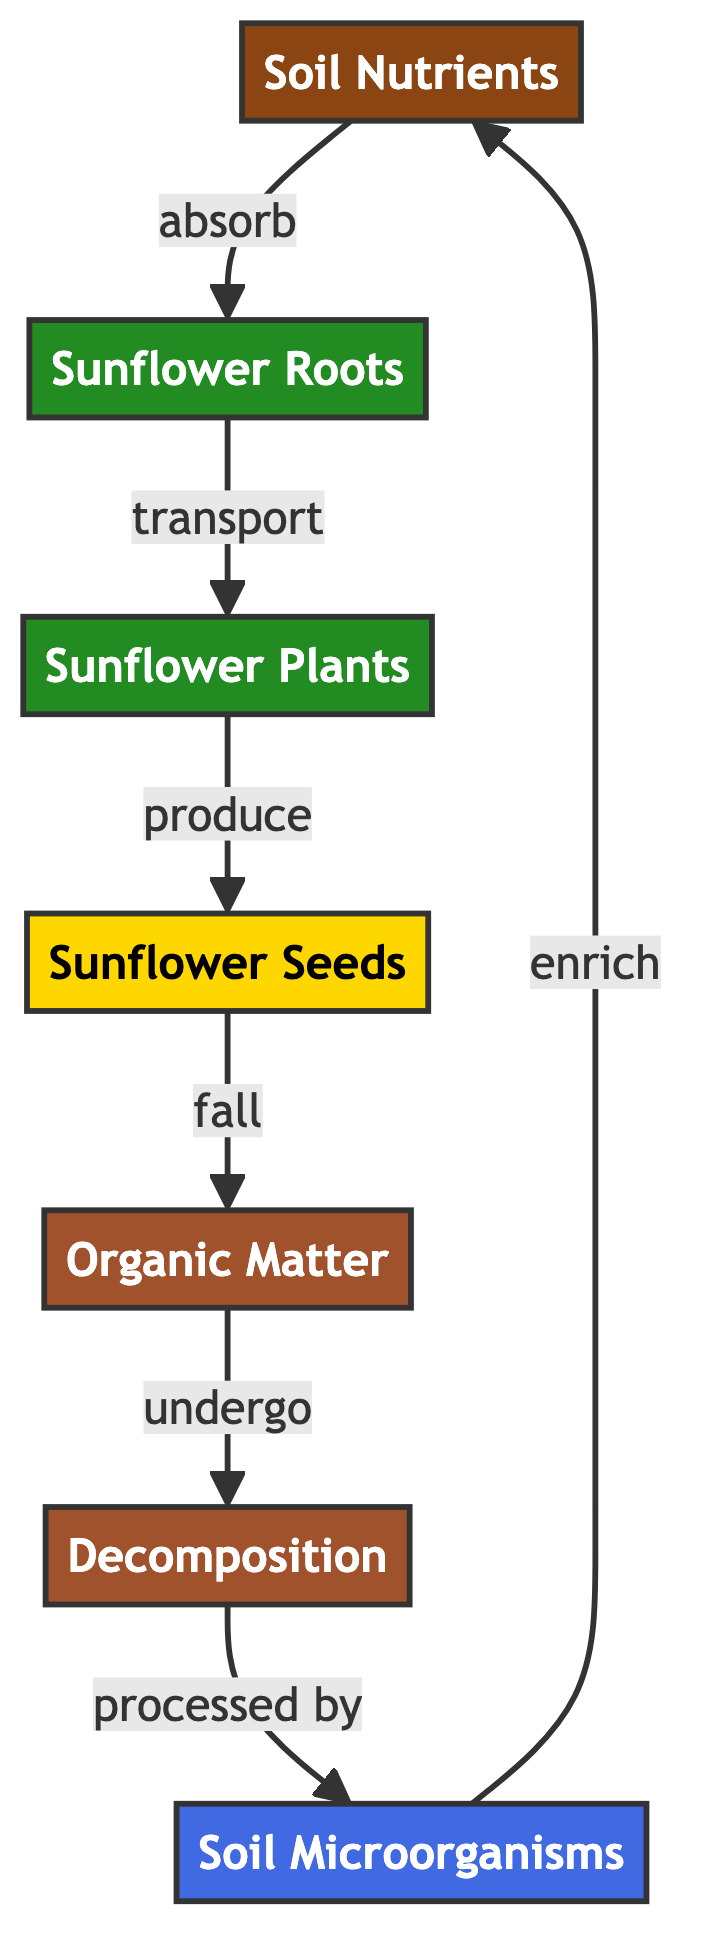What is the first component in the nutrient cycling process? The diagram shows that "Soil Nutrients" is the first component that nutrients are absorbed from to initiate the cycling process.
Answer: Soil Nutrients How many types of plants are indicated in the diagram? There are two types of plants represented: "Sunflower Roots" and "Sunflower Plants." Counting these gives a total of two types.
Answer: 2 What process occurs after sunflower seeds fall? According to the diagram, after sunflower seeds fall, they become part of "Organic Matter." This is indicated by the flow from "Sunflower Seeds" to "Organic Matter."
Answer: Organic Matter Which microorganisms are involved in the decomposition process? The diagram indicates that "Soil Microorganisms" are responsible for processing organic matter during decomposition, linking it to the enrichment of soil nutrients.
Answer: Soil Microorganisms What do the microorganisms contribute to in the soil? The diagram states that "Microorganisms" enrich the "Soil Nutrients," indicating their role in enhancing soil quality through decomposition.
Answer: Soil Nutrients How do nutrients travel from the roots to the plants? The diagram shows an arrow flowing from "Sunflower Roots" to "Sunflower Plants," indicating that nutrients are transported from the roots to the plants.
Answer: Transport What follows the decomposition of organic matter? The process shows that once organic matter undergoes decomposition, it is processed by "Microorganisms," establishing the sequential flow of nutrient cycling.
Answer: Processed by Microorganisms Which component produces sunflower seeds? The diagram specifies that "Sunflower Plants" produce "Sunflower Seeds," which indicates that this is the process responsible for seed production.
Answer: Sunflower Plants How do soil nutrients initially influence sunflowers? Initially, the diagram shows that "Soil Nutrients" are absorbed by "Sunflower Roots," which indicates the foundational role of soil nutrients in the growth of sunflowers.
Answer: Absorb 